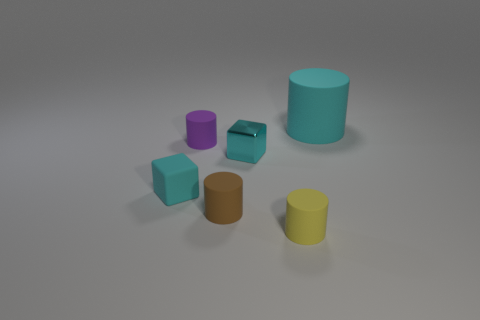How many other objects are there of the same color as the small metallic block?
Keep it short and to the point. 2. What is the size of the cyan rubber object that is on the right side of the tiny cyan cube that is left of the small rubber cylinder behind the cyan metal thing?
Keep it short and to the point. Large. There is a cyan metal cube; are there any objects in front of it?
Your answer should be very brief. Yes. Is the size of the cyan rubber cube the same as the thing in front of the small brown matte object?
Make the answer very short. Yes. What number of other things are there of the same material as the big cyan thing
Make the answer very short. 4. The cyan thing that is both on the right side of the small rubber block and left of the yellow thing has what shape?
Offer a very short reply. Cube. There is a cube that is to the right of the rubber block; is its size the same as the cube that is left of the tiny cyan metal block?
Keep it short and to the point. Yes. What is the shape of the big cyan object that is made of the same material as the brown thing?
Offer a terse response. Cylinder. There is a small cube that is left of the small cyan block on the right side of the small cube on the left side of the purple rubber object; what is its color?
Provide a succinct answer. Cyan. Is the number of matte cylinders in front of the tiny brown cylinder less than the number of cylinders that are in front of the tiny cyan matte block?
Offer a terse response. Yes. 